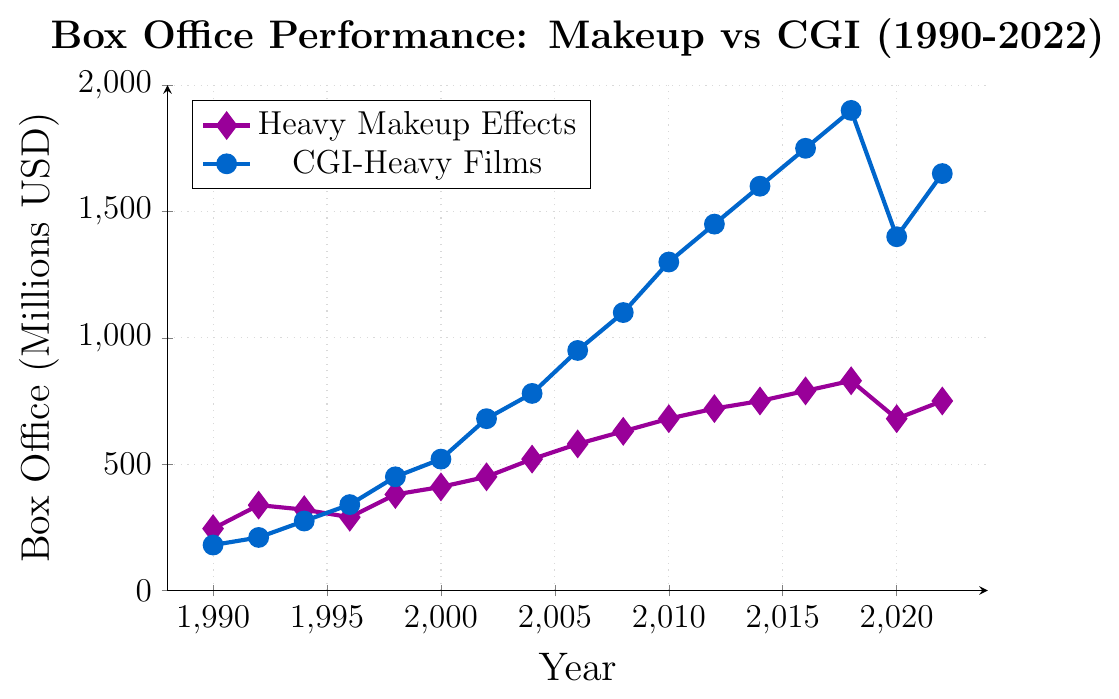What year did CGI-heavy films first surpass heavy makeup effects films in box office performance? First, locate the box office performances of both categories over time. Find the point where the performance of CGI-heavy films exceeds that of heavy makeup effects. This occurs in 1996 when CGI-heavy films earned 340 million, surpassing heavy makeup effects at 290 million.
Answer: 1996 By how much did the box office performance of CGI-heavy films exceed that of heavy makeup effects in 2008? Locate the box office performances for both categories in 2008. Subtract heavy makeup effects (630 million) from CGI-heavy films (1100 million) to find the difference. 1100 - 630 = 470.
Answer: 470 million During which year did heavy makeup effects films experience a dip in performance while CGI-heavy films continued to rise? Identify the trends for both categories over the years. For heavy makeup effects, there is a dip between 2018 (830 million) and 2020 (680 million), while CGI-heavy films drop but still perform relatively well from 2018 (1900 million) to 2020 (1400 million).
Answer: 2020 What is the average box office performance for heavy makeup effects films from 1990 to 2022? Add up the box office performance values for heavy makeup effects films across all given years and divide by the number of years. Sum: 245 + 338 + 320 + 290 + 380 + 410 + 450 + 520 + 580 + 630 + 680 + 720 + 750 + 790 + 830 + 680 + 750 = 9363. Divide by 17 years: 9363 / 17 = approximately 550.
Answer: 550 million In which period did both heavy makeup effects films and CGI-heavy films see a rise in box office performance without any decline? Scan the entire years from 1990 to 2022 for both categories. Identify the period when both show a continuous rise. This occurs from 1998 (heavy makeup: 380, CGI: 450) to 2018 (heavy makeup: 830, CGI: 1900).
Answer: 1998 to 2018 